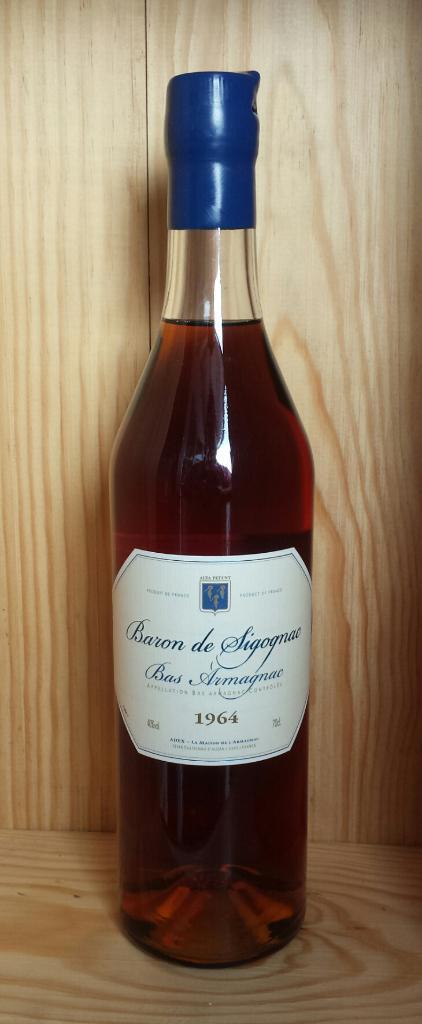Can you describe this image briefly? In this picture there is a wine bottle kept in a wooden shelf 